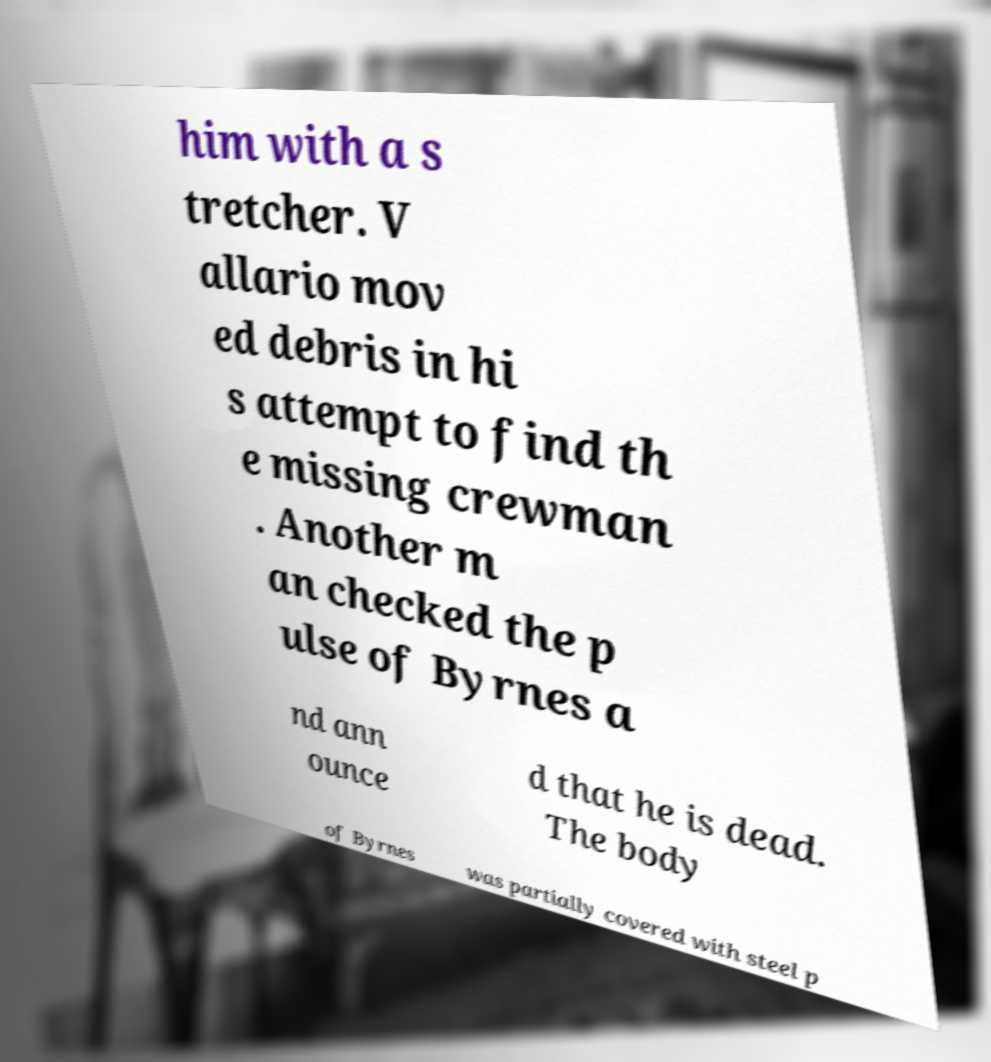I need the written content from this picture converted into text. Can you do that? him with a s tretcher. V allario mov ed debris in hi s attempt to find th e missing crewman . Another m an checked the p ulse of Byrnes a nd ann ounce d that he is dead. The body of Byrnes was partially covered with steel p 